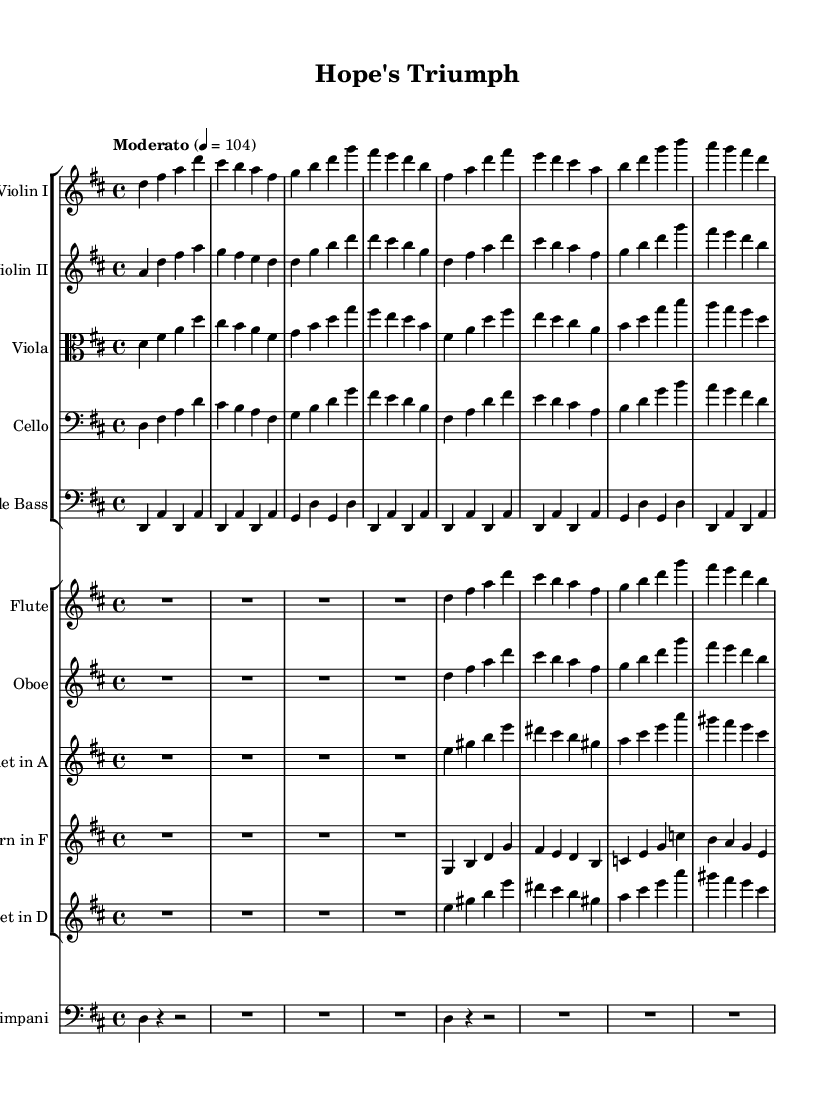What is the key signature of this piece? The key signature is indicated on the left side of the staff and shows two sharps, which represent F# and C#. This corresponds to the key of D major.
Answer: D major What is the time signature of this composition? The time signature is located at the beginning of the staff and is represented as 4/4, indicating four beats per measure, with a quarter note receiving one beat.
Answer: 4/4 What is the tempo marking of the music? The tempo marking is mentioned above the first measure and indicates "Moderato" with a metronome mark of 104 beats per minute. This describes the speed at which the piece should be played.
Answer: Moderato Which instrument has the lowest pitch range in this score? The cello part typically plays in a lower pitch range compared to the other string instruments, such as violins and violas. The cello is indicated with a bass clef, confirming it as the lowest instrument in this orchestral setting.
Answer: Cello How many distinct instruments are featured in this piece? To find the number of distinct instruments, I can count the different staff groups in the score. There are five string instruments (two violins, viola, cello, double bass) and five woodwinds/brass instruments (flute, oboe, clarinet, horn, trumpet), making a total of ten distinct instruments.
Answer: Ten What form of music does this piece represent? The composition is part of the Romantic era, characterized by emotional expression, rich orchestration, and thematic development. The style of the piece celebrates breakthroughs in medical research through a hopeful and uplifting orchestral arrangement, typical of Romantic traditions.
Answer: Romantic 